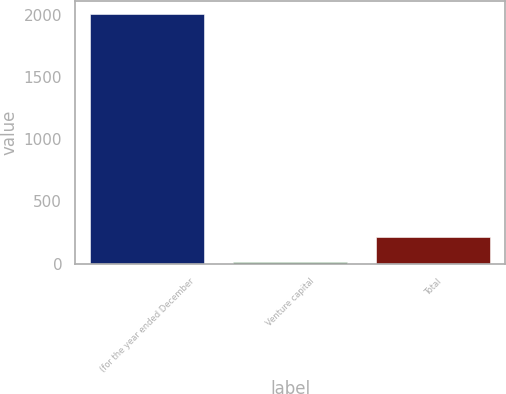Convert chart to OTSL. <chart><loc_0><loc_0><loc_500><loc_500><bar_chart><fcel>(for the year ended December<fcel>Venture capital<fcel>Total<nl><fcel>2007<fcel>16<fcel>215.1<nl></chart> 